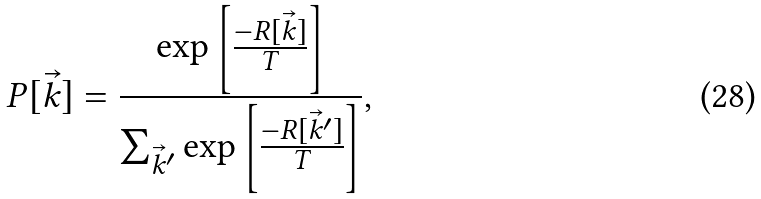Convert formula to latex. <formula><loc_0><loc_0><loc_500><loc_500>P [ \vec { k } ] = \frac { \exp \left [ \frac { - R [ \vec { k } ] } { T } \right ] } { \sum _ { \vec { k } ^ { \prime } } \exp \left [ \frac { - R [ \vec { k } ^ { \prime } ] } { T } \right ] } ,</formula> 